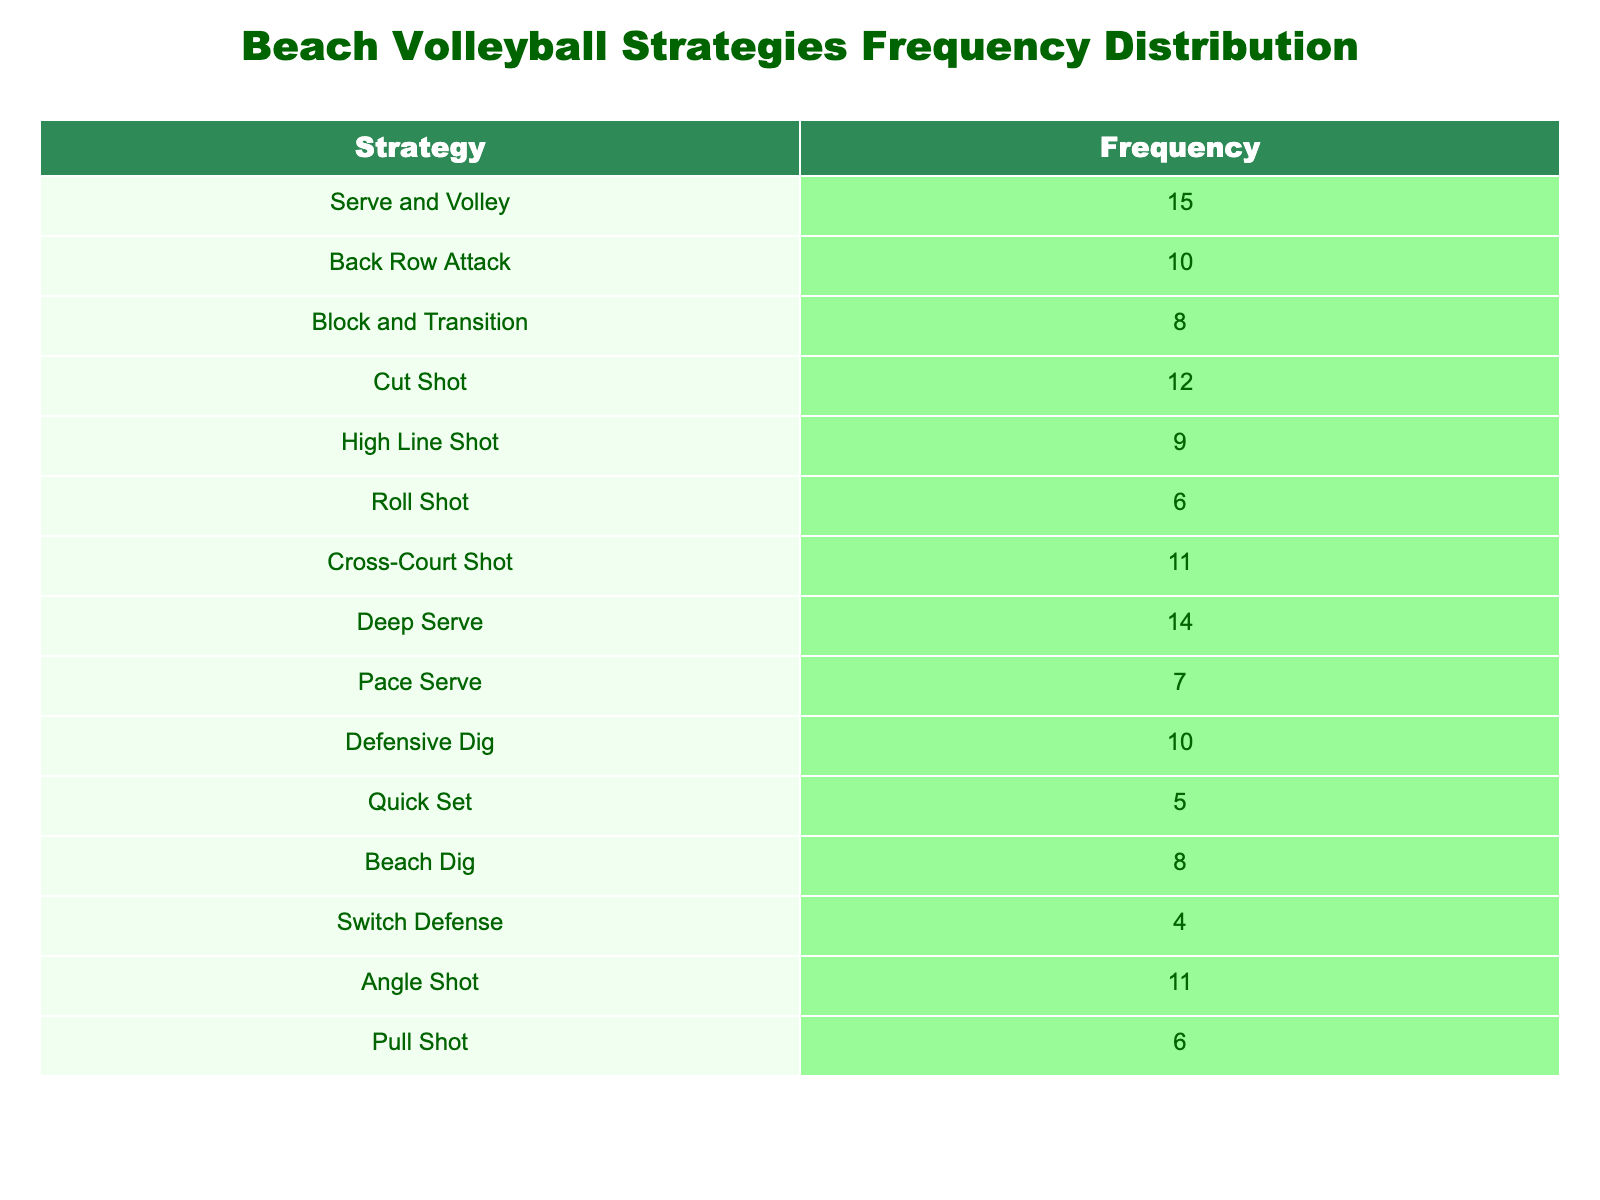What is the frequency of the "Back Row Attack" strategy? The table lists the frequency of each strategy used during matches. According to the table, the "Back Row Attack" strategy has a frequency of 10.
Answer: 10 Which strategy has the highest frequency? By reviewing the table, we see that the "Serve and Volley" strategy has the highest frequency of 15 among all strategies listed.
Answer: Serve and Volley What is the total frequency of all strategies combined? To find the total frequency, we add all frequencies together: 15 + 10 + 8 + 12 + 9 + 6 + 11 + 14 + 7 + 10 + 5 + 8 + 4 + 11 + 6 =  13 + 19 + 22 + 27 + 38 = 40 + 22 + 47 = 49 + 15 = 98. Therefore, the total frequency sums up to 98.
Answer: 98 Is the frequency of "Quick Set" greater than that of "Pace Serve"? By comparing the frequencies listed in the table, "Quick Set" has a frequency of 5 while "Pace Serve" has a frequency of 7. Since 5 is less than 7, the statement is false.
Answer: No What is the combined frequency of strategies related to offensive plays (Serve and Volley, Back Row Attack, Cut Shot, High Line Shot, Roll Shot, Cross-Court Shot)? The frequencies for these offensive strategies are: Serve and Volley (15), Back Row Attack (10), Cut Shot (12), High Line Shot (9), Roll Shot (6), and Cross-Court Shot (11). Adding these together: 15 + 10 + 12 + 9 + 6 + 11 = 63. Therefore, the combined frequency of these offensive strategies is 63.
Answer: 63 How many strategies have a frequency of 10 or more? By examining the table, we can count the strategies with frequencies of 10 or more: Serve and Volley (15), Back Row Attack (10), Cut Shot (12), Deep Serve (14), Cross-Court Shot (11), and Angle Shot (11). That sums up to 6 strategies in total.
Answer: 6 What is the average frequency of the strategies listed? To calculate the average frequency, first, we find the total frequency, which is 98 (as previously calculated), and then divide this total by the number of strategies listed, which is 15. Thus, the average frequency is 98 / 15, which equals approximately 6.53.
Answer: 6.53 Is "Defensive Dig" more frequently used than "Beach Dig"? The table shows "Defensive Dig" has a frequency of 10 and "Beach Dig" has a frequency of 8. Since 10 is greater than 8, the answer is yes.
Answer: Yes 